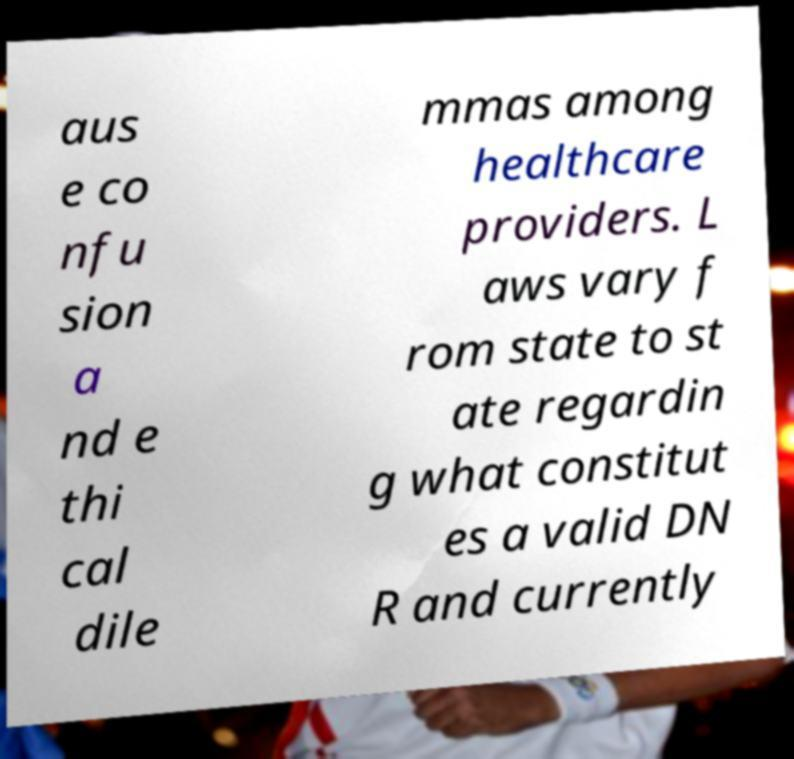Please identify and transcribe the text found in this image. aus e co nfu sion a nd e thi cal dile mmas among healthcare providers. L aws vary f rom state to st ate regardin g what constitut es a valid DN R and currently 